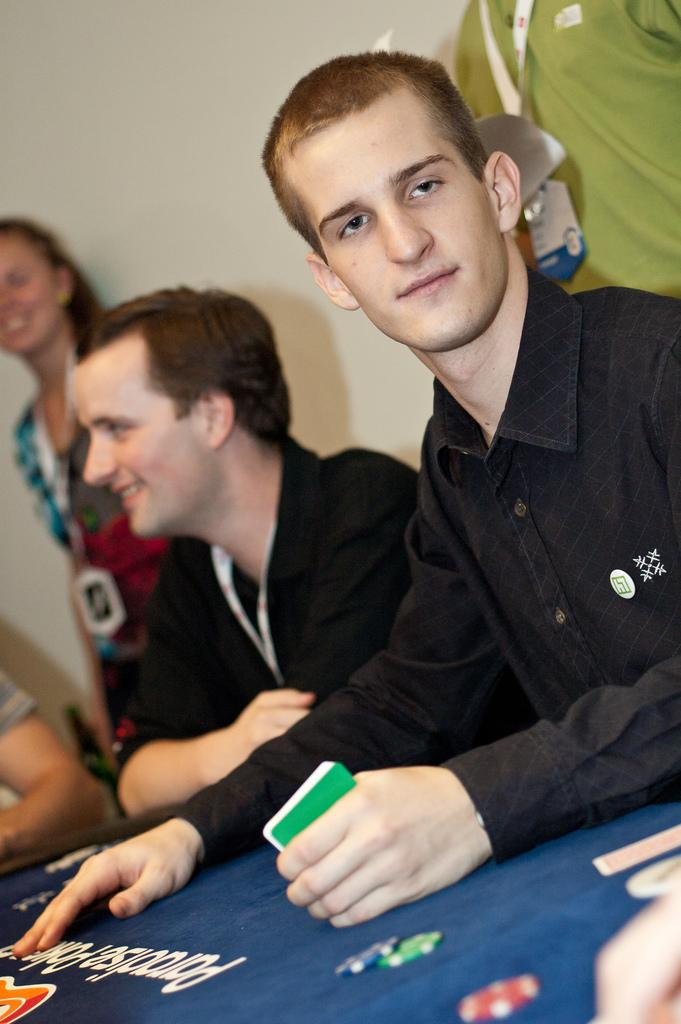How many people are sitting at the table in the image? There are two persons sitting at the table in the image. What is one of the persons holding in his hands? One of the persons is holding cards in his hands. Can you describe the background of the image? There are other persons in the background, and there is a wall in the background. What type of silk is being used to make the cap worn by the person in the image? There is no cap or silk present in the image. Can you describe the volcano visible in the background of the image? There is no volcano present in the image; the background features other persons and a wall. 